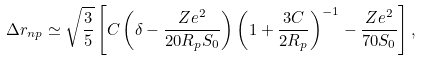Convert formula to latex. <formula><loc_0><loc_0><loc_500><loc_500>\Delta r _ { n p } \simeq \sqrt { \frac { 3 } { 5 } } \left [ C \left ( \delta - \frac { Z e ^ { 2 } } { 2 0 R _ { p } S _ { 0 } } \right ) \left ( 1 + \frac { 3 C } { 2 R _ { p } } \right ) ^ { - 1 } - \frac { Z e ^ { 2 } } { 7 0 S _ { 0 } } \right ] ,</formula> 